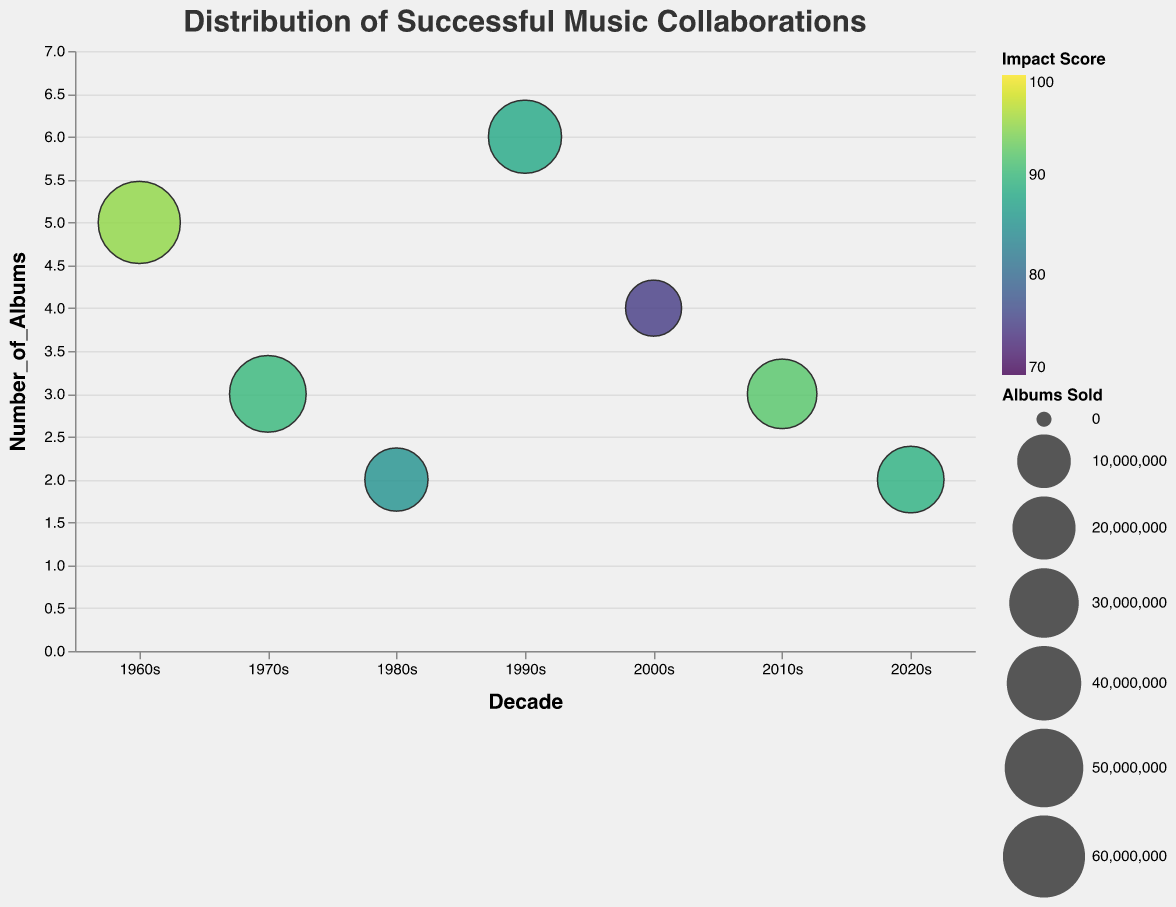What's the title of the figure? The title is found at the top of the figure; it serves as a heading that summarizes the data being visualized.
Answer: Distribution of Successful Music Collaborations Which decade has the collaboration with the highest impact score? By examining the colors of the bubbles, the darkest color represents the highest impact score.
Answer: 1960s How many albums did the Radiohead & Nigel Godrich collaboration produce? Look at the "Number of Albums" axis and find the bubble corresponding to Radiohead & Nigel Godrich.
Answer: 4 In which decade did the collaboration with the least number of albums take place? Compare the "Number of Albums" values along the y-axis and find the smallest value.
Answer: 1980s and 2020s Compare the bubbles for the 1970s and 2010s; which one represents more albums sold? Look at the size of the bubbles; the larger bubble represents more albums sold.
Answer: 1970s Which decade has the most collaborations of 3 albums? Count the number of bubbles with a "Number of Albums" value of 3 for each decade.
Answer: 1970s and 2010s What's the total impact score for all the collaborations in the 1960s and 2000s? Sum the impact scores of all data points in the 1960s and 2000s (95 + 75).
Answer: 170 Which collaboration produced the highest number of albums, and in which decade did it occur? Identify the tallest bubble and read off the "Decade" and "Collaboration" from its tooltip.
Answer: Red Hot Chili Peppers & Rick Rubin, 1990s How does the Pink Floyd & Alan Parsons collaboration in the 1970s compare to the David Bowie & Nile Rodgers collaboration in the 1980s in terms of albums sold? Examine the size of both bubbles, finding the values from the tooltip and compare them.
Answer: Pink Floyd & Alan Parsons sold more albums (45000000 vs. 20000000) 